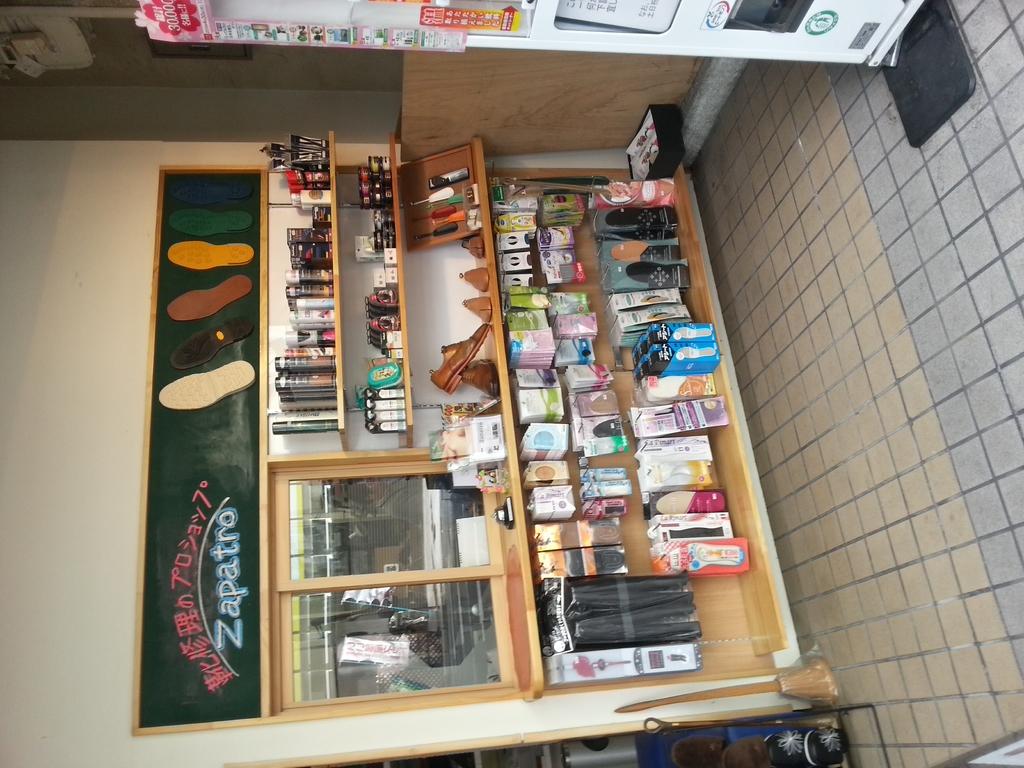What does the sign with the shoe prints say?
Your response must be concise. Zapatro. 